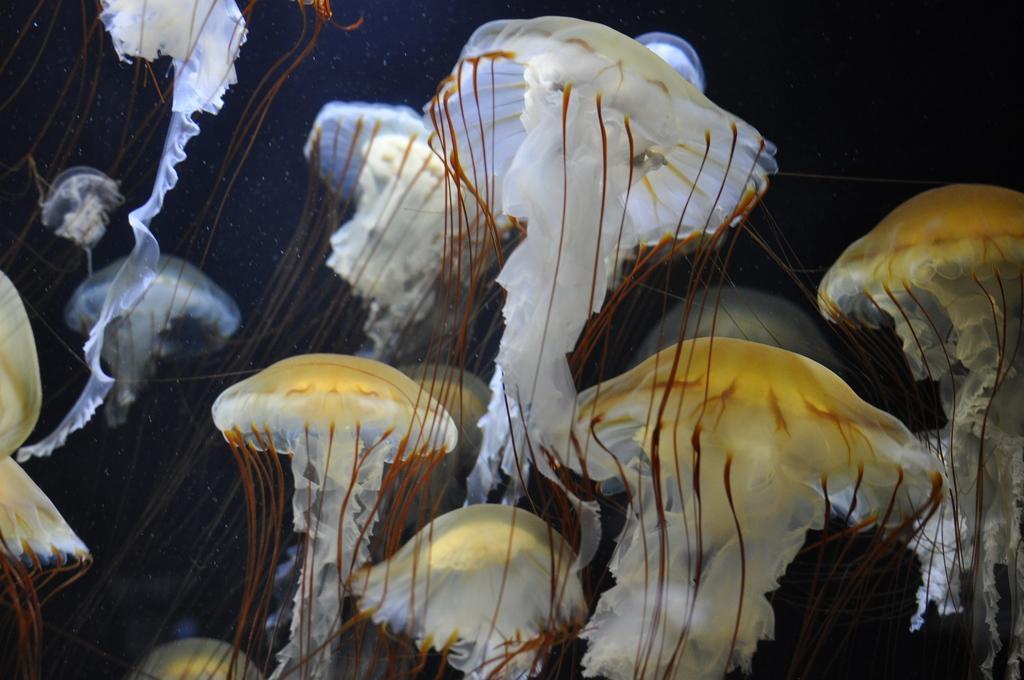Can you describe this image briefly? In the center of the image we can see jelly fishes underwater. 